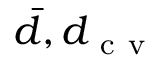<formula> <loc_0><loc_0><loc_500><loc_500>\bar { d } , d _ { c v }</formula> 